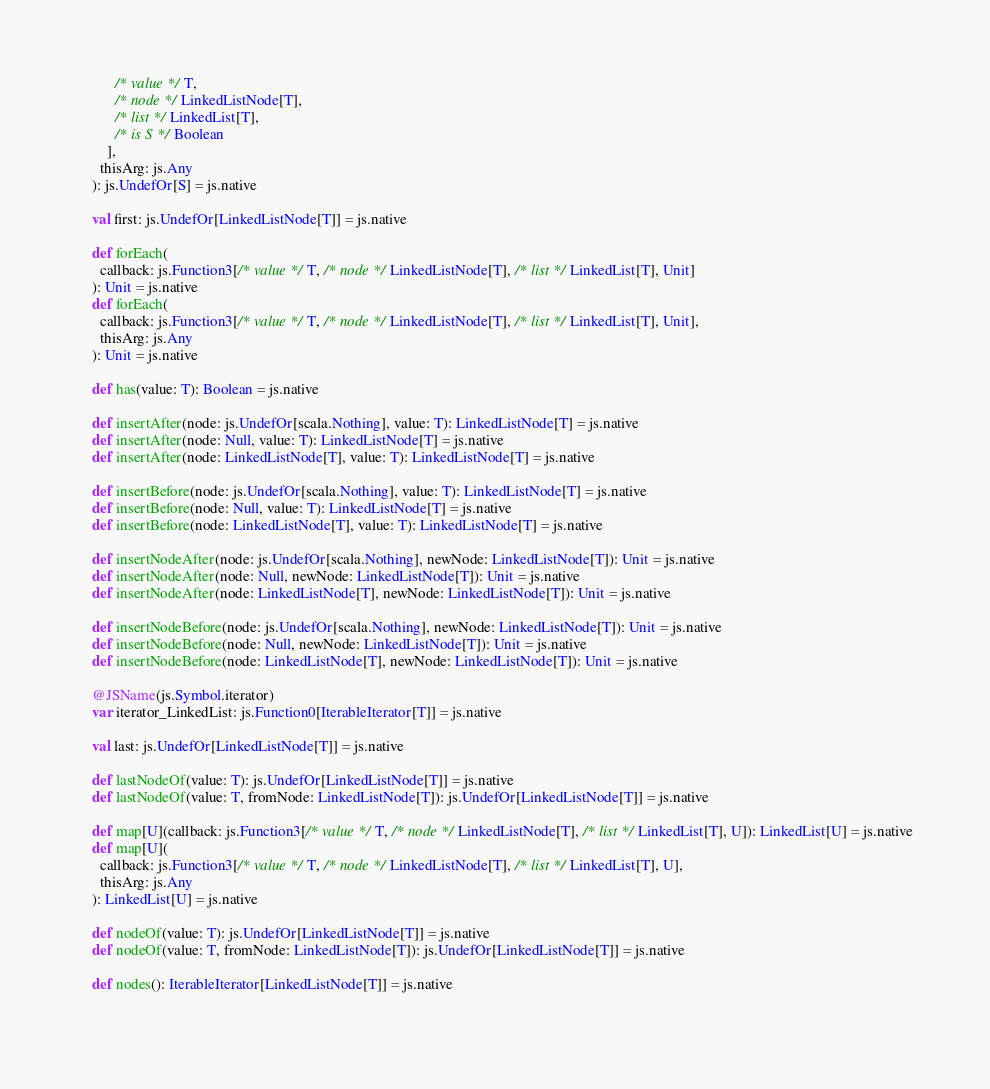<code> <loc_0><loc_0><loc_500><loc_500><_Scala_>          /* value */ T, 
          /* node */ LinkedListNode[T], 
          /* list */ LinkedList[T], 
          /* is S */ Boolean
        ],
      thisArg: js.Any
    ): js.UndefOr[S] = js.native
    
    val first: js.UndefOr[LinkedListNode[T]] = js.native
    
    def forEach(
      callback: js.Function3[/* value */ T, /* node */ LinkedListNode[T], /* list */ LinkedList[T], Unit]
    ): Unit = js.native
    def forEach(
      callback: js.Function3[/* value */ T, /* node */ LinkedListNode[T], /* list */ LinkedList[T], Unit],
      thisArg: js.Any
    ): Unit = js.native
    
    def has(value: T): Boolean = js.native
    
    def insertAfter(node: js.UndefOr[scala.Nothing], value: T): LinkedListNode[T] = js.native
    def insertAfter(node: Null, value: T): LinkedListNode[T] = js.native
    def insertAfter(node: LinkedListNode[T], value: T): LinkedListNode[T] = js.native
    
    def insertBefore(node: js.UndefOr[scala.Nothing], value: T): LinkedListNode[T] = js.native
    def insertBefore(node: Null, value: T): LinkedListNode[T] = js.native
    def insertBefore(node: LinkedListNode[T], value: T): LinkedListNode[T] = js.native
    
    def insertNodeAfter(node: js.UndefOr[scala.Nothing], newNode: LinkedListNode[T]): Unit = js.native
    def insertNodeAfter(node: Null, newNode: LinkedListNode[T]): Unit = js.native
    def insertNodeAfter(node: LinkedListNode[T], newNode: LinkedListNode[T]): Unit = js.native
    
    def insertNodeBefore(node: js.UndefOr[scala.Nothing], newNode: LinkedListNode[T]): Unit = js.native
    def insertNodeBefore(node: Null, newNode: LinkedListNode[T]): Unit = js.native
    def insertNodeBefore(node: LinkedListNode[T], newNode: LinkedListNode[T]): Unit = js.native
    
    @JSName(js.Symbol.iterator)
    var iterator_LinkedList: js.Function0[IterableIterator[T]] = js.native
    
    val last: js.UndefOr[LinkedListNode[T]] = js.native
    
    def lastNodeOf(value: T): js.UndefOr[LinkedListNode[T]] = js.native
    def lastNodeOf(value: T, fromNode: LinkedListNode[T]): js.UndefOr[LinkedListNode[T]] = js.native
    
    def map[U](callback: js.Function3[/* value */ T, /* node */ LinkedListNode[T], /* list */ LinkedList[T], U]): LinkedList[U] = js.native
    def map[U](
      callback: js.Function3[/* value */ T, /* node */ LinkedListNode[T], /* list */ LinkedList[T], U],
      thisArg: js.Any
    ): LinkedList[U] = js.native
    
    def nodeOf(value: T): js.UndefOr[LinkedListNode[T]] = js.native
    def nodeOf(value: T, fromNode: LinkedListNode[T]): js.UndefOr[LinkedListNode[T]] = js.native
    
    def nodes(): IterableIterator[LinkedListNode[T]] = js.native
    </code> 